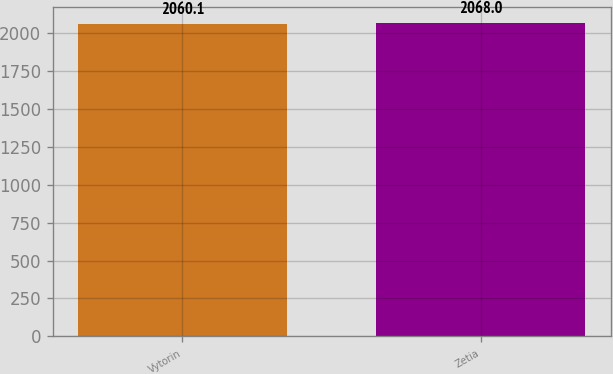Convert chart to OTSL. <chart><loc_0><loc_0><loc_500><loc_500><bar_chart><fcel>Vytorin<fcel>Zetia<nl><fcel>2060.1<fcel>2068<nl></chart> 